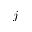<formula> <loc_0><loc_0><loc_500><loc_500>j</formula> 